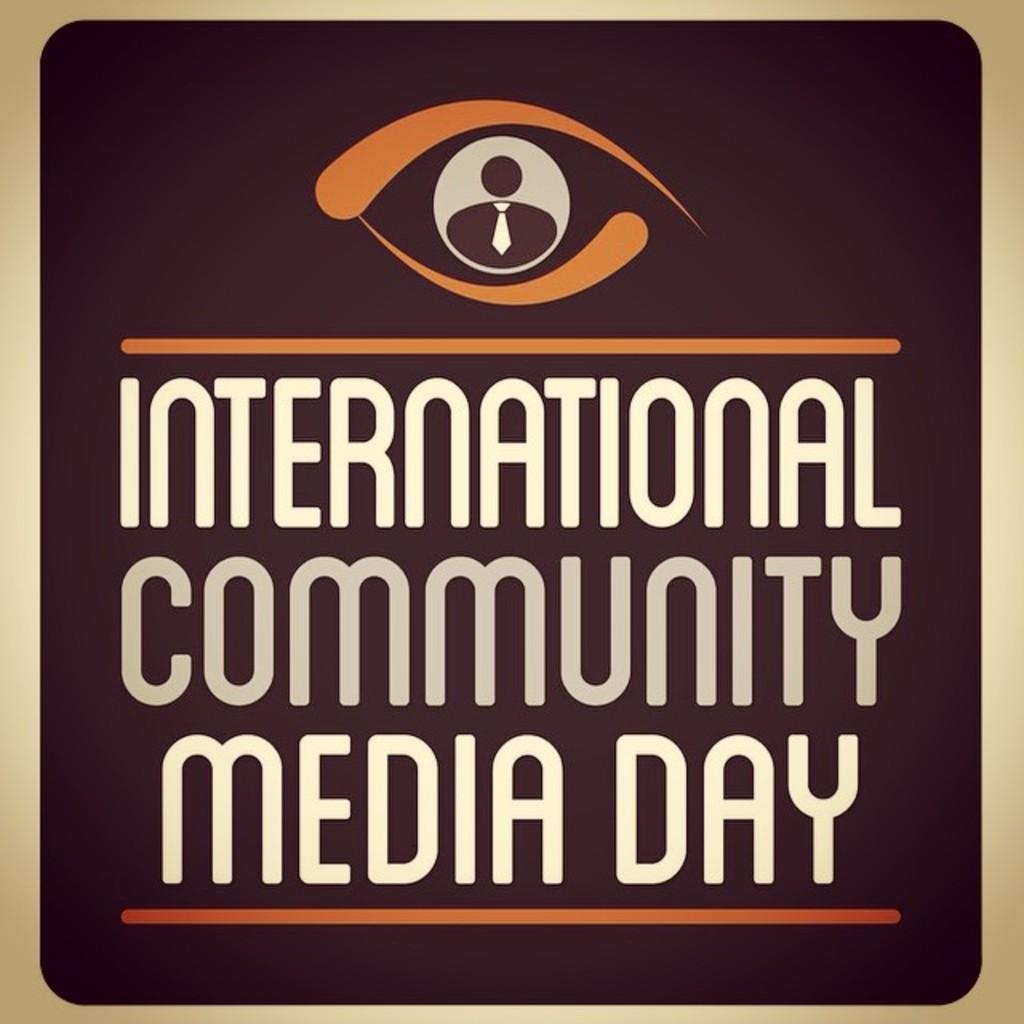<image>
Present a compact description of the photo's key features. a page that says 'international community media day' on it 